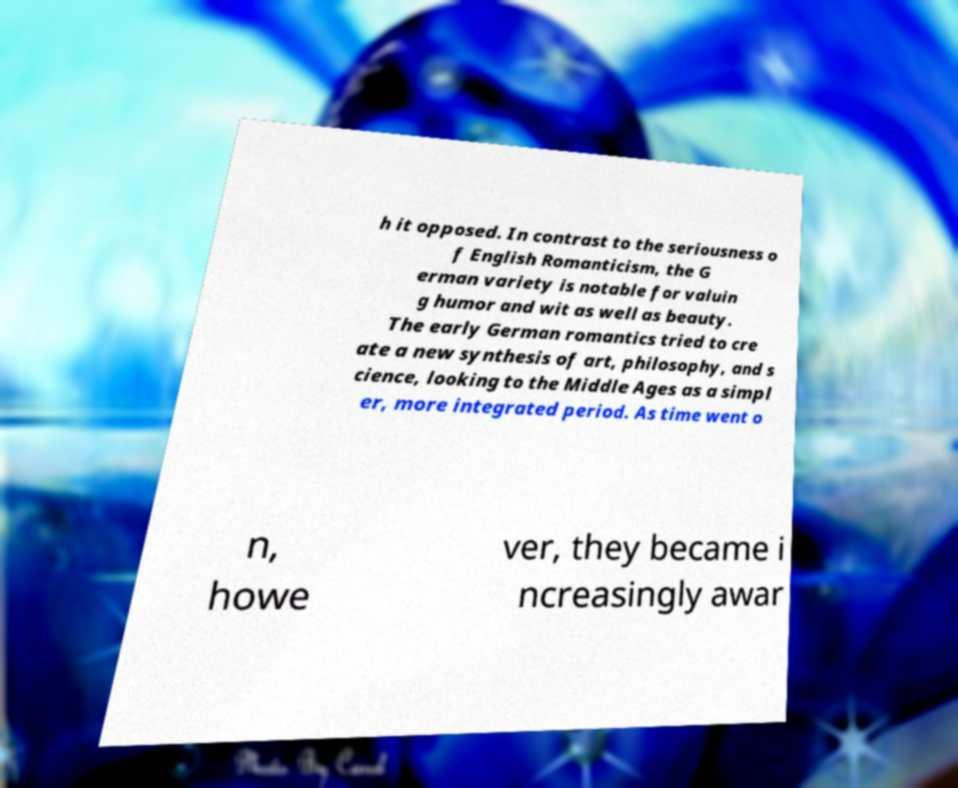Please read and relay the text visible in this image. What does it say? h it opposed. In contrast to the seriousness o f English Romanticism, the G erman variety is notable for valuin g humor and wit as well as beauty. The early German romantics tried to cre ate a new synthesis of art, philosophy, and s cience, looking to the Middle Ages as a simpl er, more integrated period. As time went o n, howe ver, they became i ncreasingly awar 